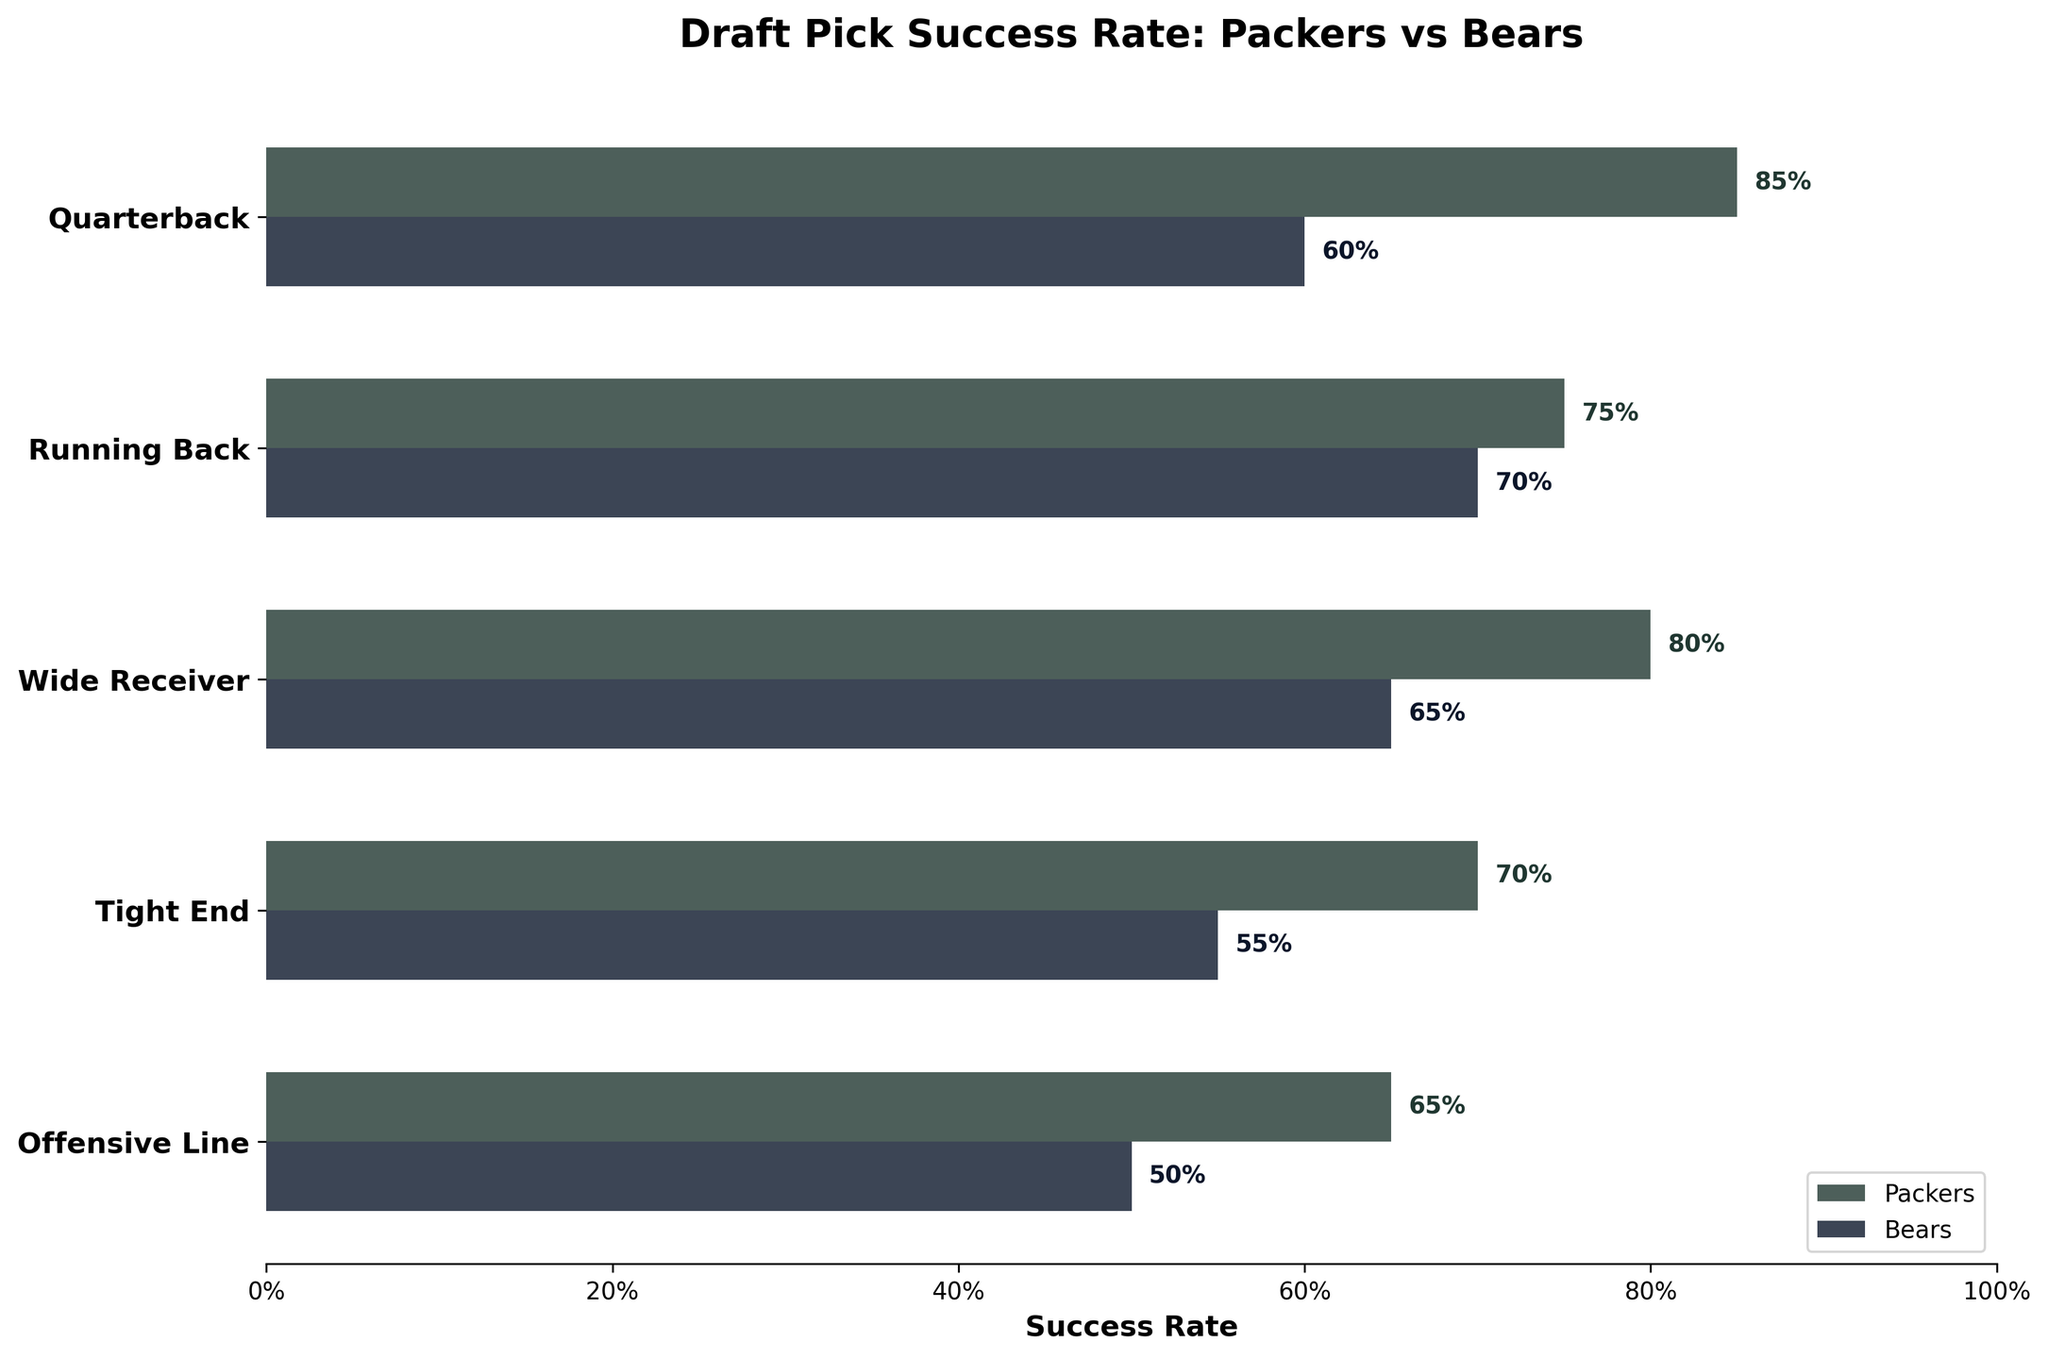Which team has a higher success rate for drafting offensive linemen? The Packers' success rate for offensive linemen is 65%, while the Bears' success rate is 50%.
Answer: Packers What is the success rate difference between Packers and Bears for quarterbacks? The Packers have an 85% success rate for quarterbacks, while the Bears have a 60% success rate. The difference is 85% - 60% = 25%.
Answer: 25% Which offensive position has the smallest success rate difference between Packers and Bears? The position with the smallest success rate difference is Running Back. The Packers have a 75% success rate, and the Bears have a 70% success rate. The difference is 75% - 70% = 5%.
Answer: Running Back What is the average success rate for the Packers across all offensive positions? The success rates for the Packers are 85% (quarterback), 75% (running back), 80% (wide receiver), 70% (tight end), and 65% (offensive line). The average is (85 + 75 + 80 + 70 + 65) / 5 = 75%.
Answer: 75% How many offensive positions have the Packers with a higher success rate than the Bears? All listed positions have higher success rates for the Packers compared to the Bears: quarterback (85% vs 60%), running back (75% vs 70%), wide receiver (80% vs 65%), tight end (70% vs 55%), and offensive line (65% vs 50%).
Answer: 5 Which position shows the most significant discrepancy in success rates between Packers and Bears? The quarterback position shows the biggest discrepancy, with the Packers having an 85% success rate compared to the Bears' 60%, a difference of 25%.
Answer: Quarterback In how many positions do both teams show a success rate of 70% or above? Only running back has both teams with a success rate of 70% or above (Packers: 75%, Bears: 70%).
Answer: 1 Which team has a better overall success rate in drafting offensive players based on this data? Each position listed shows that the Packers have a higher success rate than the Bears.
Answer: Packers 